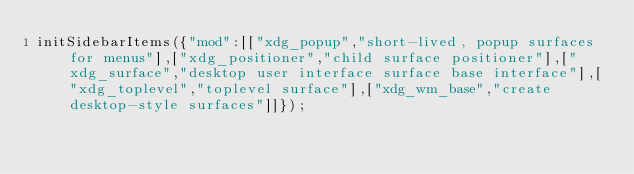<code> <loc_0><loc_0><loc_500><loc_500><_JavaScript_>initSidebarItems({"mod":[["xdg_popup","short-lived, popup surfaces for menus"],["xdg_positioner","child surface positioner"],["xdg_surface","desktop user interface surface base interface"],["xdg_toplevel","toplevel surface"],["xdg_wm_base","create desktop-style surfaces"]]});</code> 